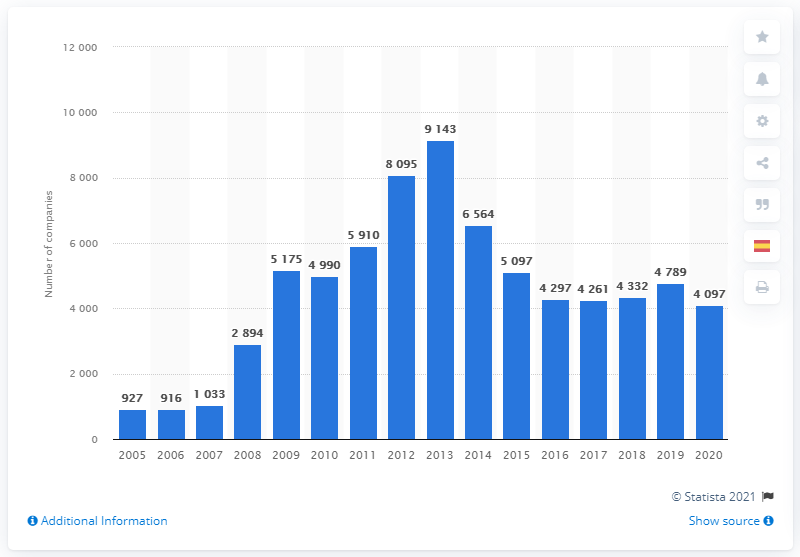When did the number of companies declared bankrupt start decreasing?
 2013 